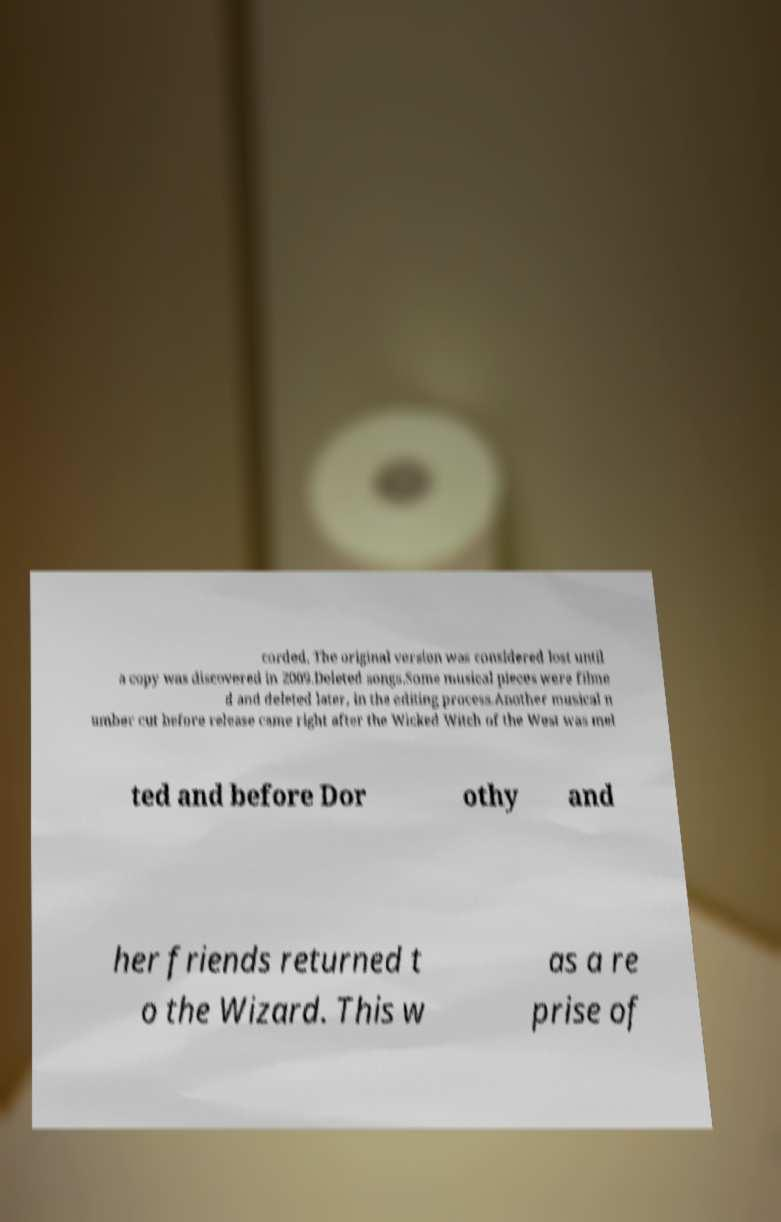There's text embedded in this image that I need extracted. Can you transcribe it verbatim? corded. The original version was considered lost until a copy was discovered in 2009.Deleted songs.Some musical pieces were filme d and deleted later, in the editing process.Another musical n umber cut before release came right after the Wicked Witch of the West was mel ted and before Dor othy and her friends returned t o the Wizard. This w as a re prise of 